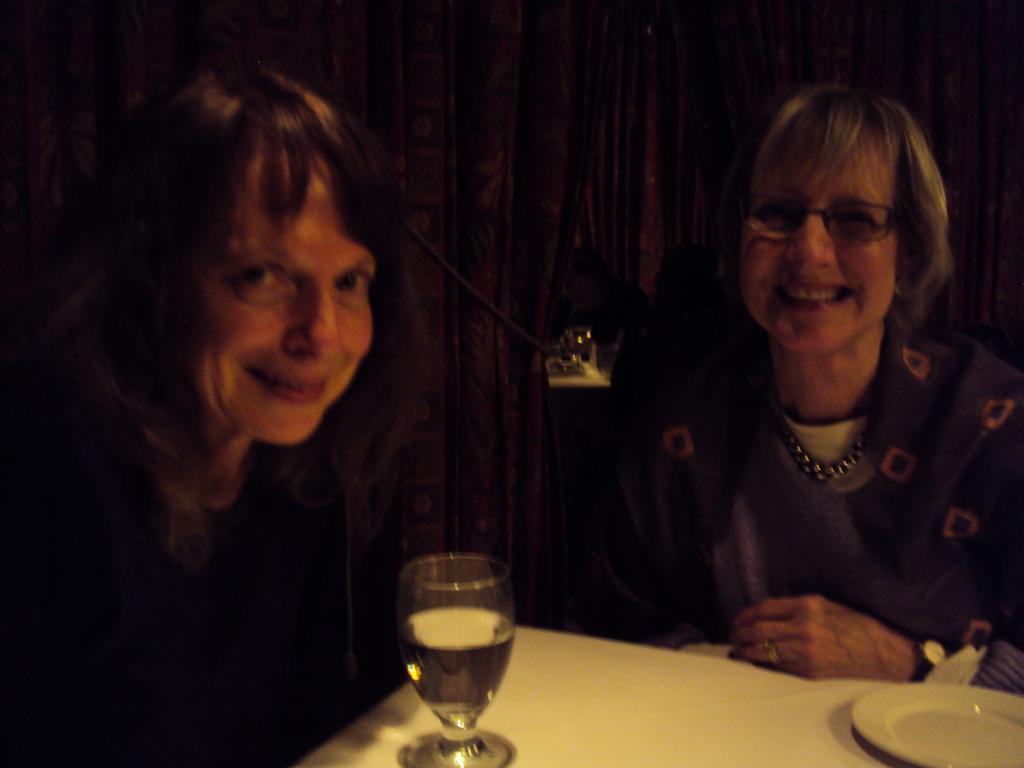How many people are in the image? There are two women in the image. What is present on the table in the image? There is a glass and a plate on the table in the image. What type of wall is visible in the background of the image? There is a wooden wall in the background of the image. Reasoning: Let'g: Let's think step by step in order to produce the conversation. We start by identifying the number of people in the image, which is two women. Then, we describe the objects on the table, which are a glass and a plate. Finally, we mention the type of wall visible in the background, which is wooden. Absurd Question/Answer: What type of pet is sitting on the crate in the image? There is no pet or crate present in the image. What type of flight is depicted in the image? There is no flight depicted in the image; it features two women, a table with a glass and a plate, and a wooden wall in the background. 